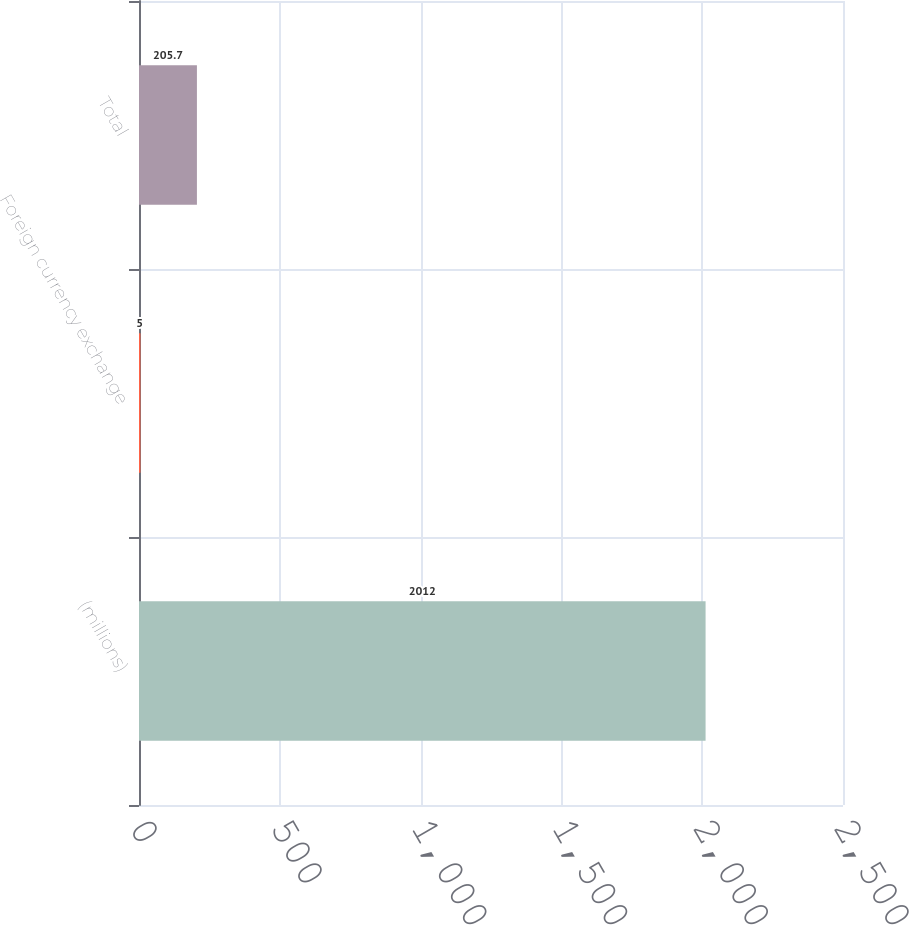Convert chart. <chart><loc_0><loc_0><loc_500><loc_500><bar_chart><fcel>(millions)<fcel>Foreign currency exchange<fcel>Total<nl><fcel>2012<fcel>5<fcel>205.7<nl></chart> 